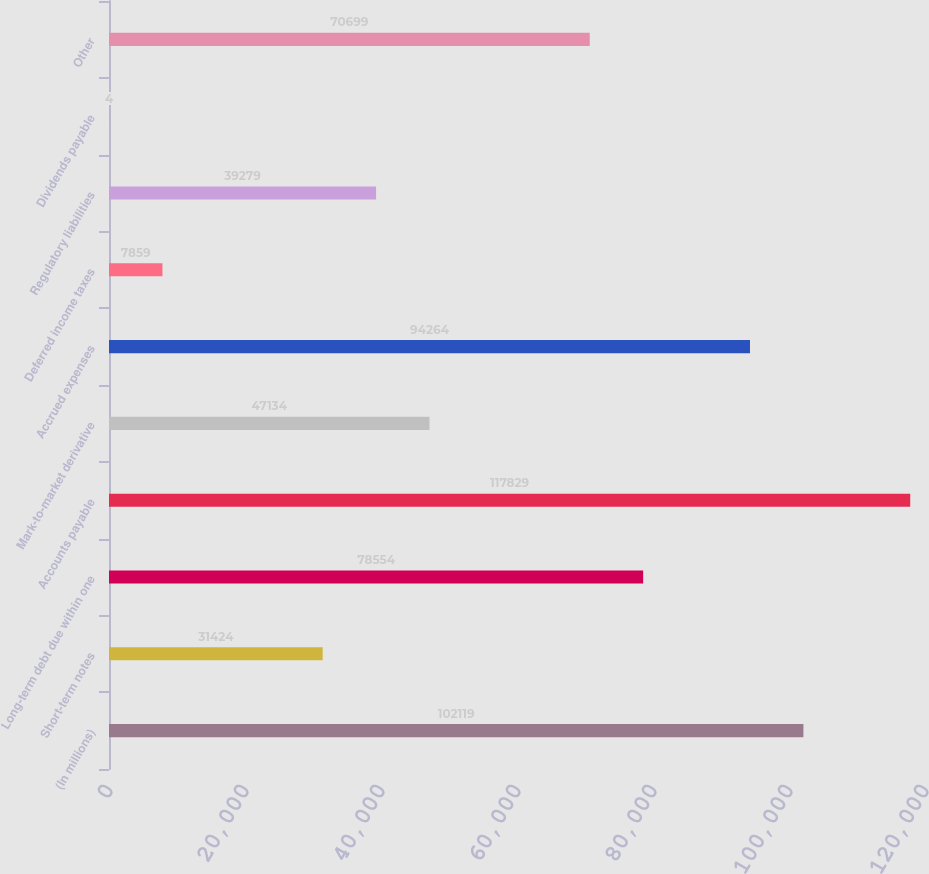<chart> <loc_0><loc_0><loc_500><loc_500><bar_chart><fcel>(In millions)<fcel>Short-term notes<fcel>Long-term debt due within one<fcel>Accounts payable<fcel>Mark-to-market derivative<fcel>Accrued expenses<fcel>Deferred income taxes<fcel>Regulatory liabilities<fcel>Dividends payable<fcel>Other<nl><fcel>102119<fcel>31424<fcel>78554<fcel>117829<fcel>47134<fcel>94264<fcel>7859<fcel>39279<fcel>4<fcel>70699<nl></chart> 